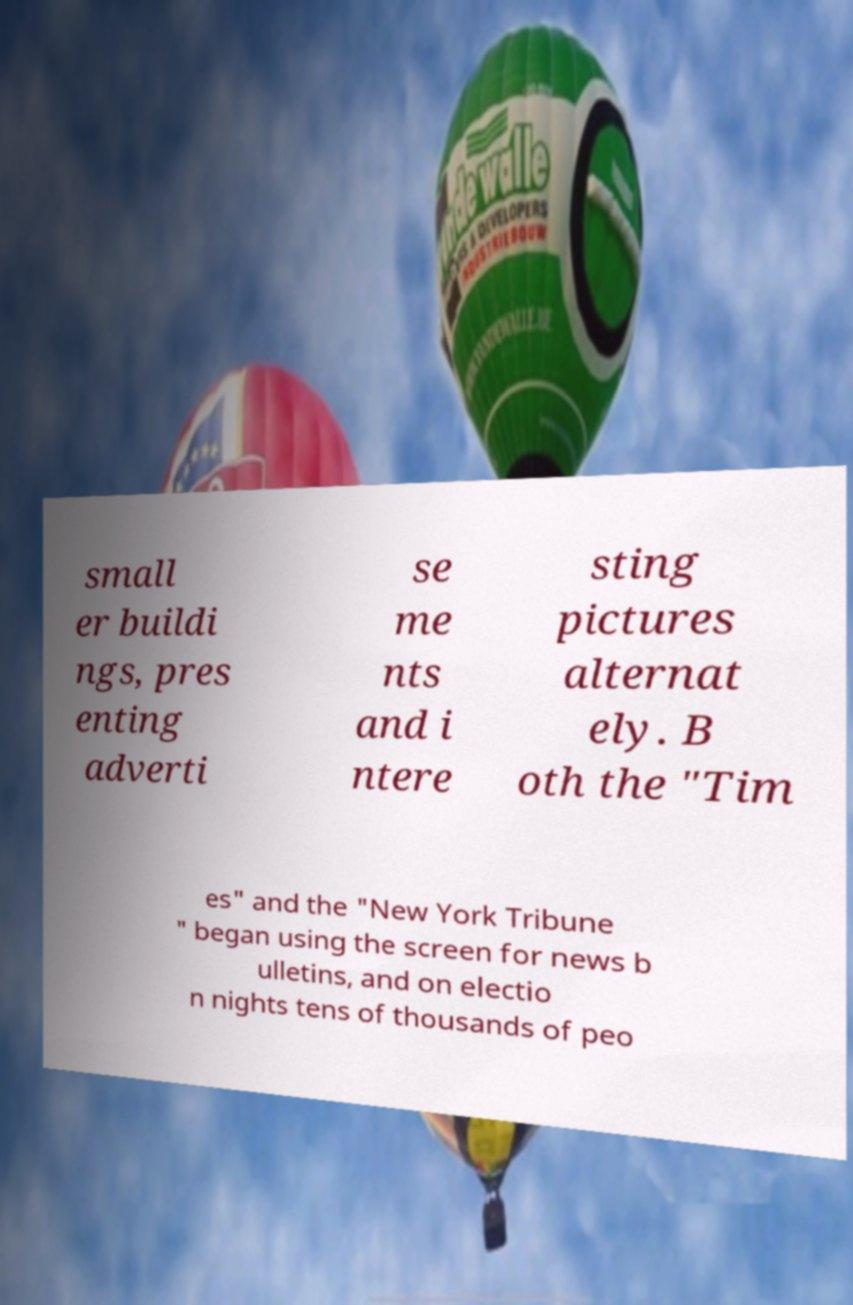Could you extract and type out the text from this image? small er buildi ngs, pres enting adverti se me nts and i ntere sting pictures alternat ely. B oth the "Tim es" and the "New York Tribune " began using the screen for news b ulletins, and on electio n nights tens of thousands of peo 